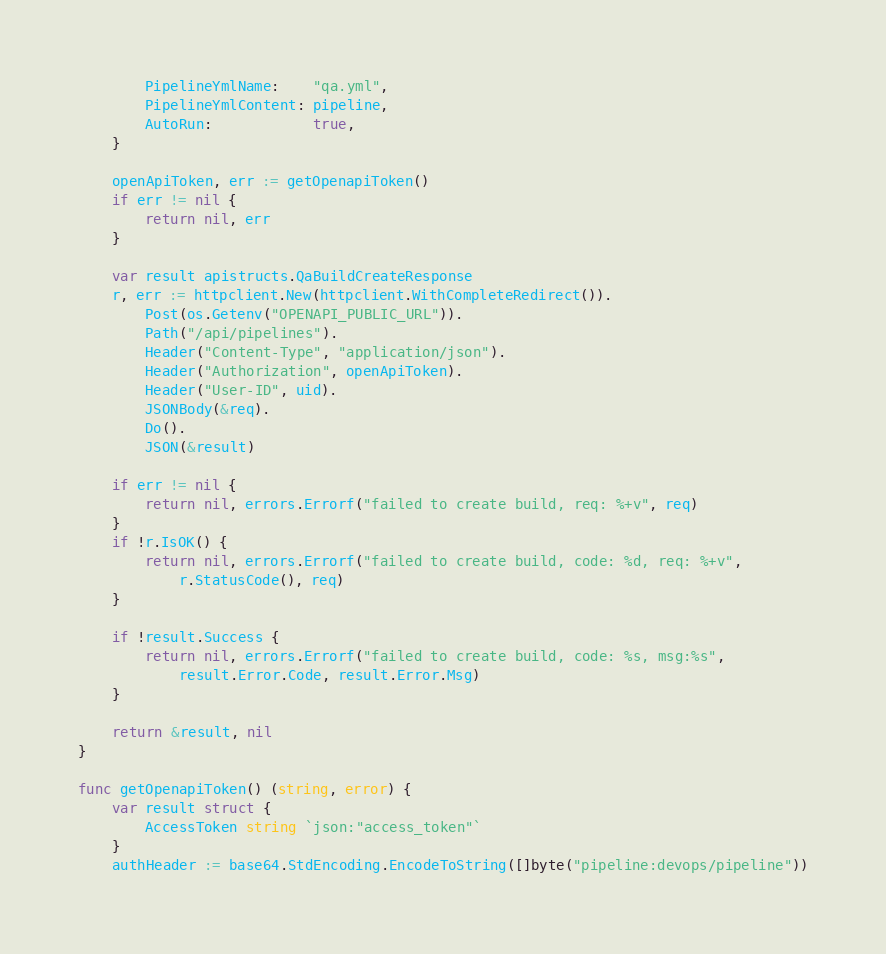Convert code to text. <code><loc_0><loc_0><loc_500><loc_500><_Go_>		PipelineYmlName:    "qa.yml",
		PipelineYmlContent: pipeline,
		AutoRun:            true,
	}

	openApiToken, err := getOpenapiToken()
	if err != nil {
		return nil, err
	}

	var result apistructs.QaBuildCreateResponse
	r, err := httpclient.New(httpclient.WithCompleteRedirect()).
		Post(os.Getenv("OPENAPI_PUBLIC_URL")).
		Path("/api/pipelines").
		Header("Content-Type", "application/json").
		Header("Authorization", openApiToken).
		Header("User-ID", uid).
		JSONBody(&req).
		Do().
		JSON(&result)

	if err != nil {
		return nil, errors.Errorf("failed to create build, req: %+v", req)
	}
	if !r.IsOK() {
		return nil, errors.Errorf("failed to create build, code: %d, req: %+v",
			r.StatusCode(), req)
	}

	if !result.Success {
		return nil, errors.Errorf("failed to create build, code: %s, msg:%s",
			result.Error.Code, result.Error.Msg)
	}

	return &result, nil
}

func getOpenapiToken() (string, error) {
	var result struct {
		AccessToken string `json:"access_token"`
	}
	authHeader := base64.StdEncoding.EncodeToString([]byte("pipeline:devops/pipeline"))</code> 